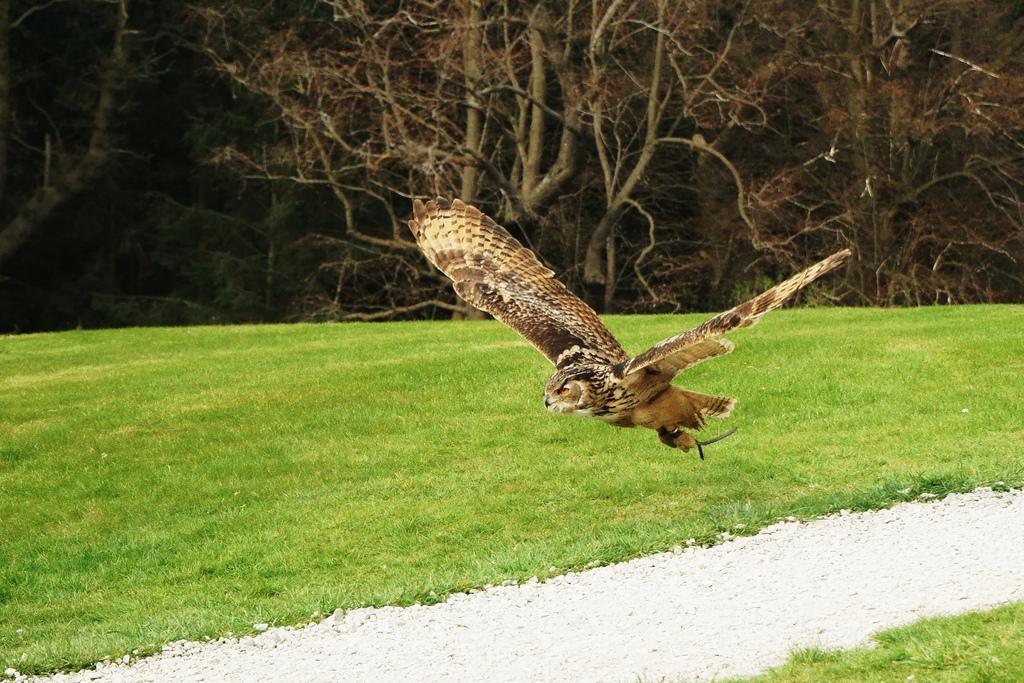Describe this image in one or two sentences. In the center of the image there is a eagle flying. In the background we can see grass and trees. 